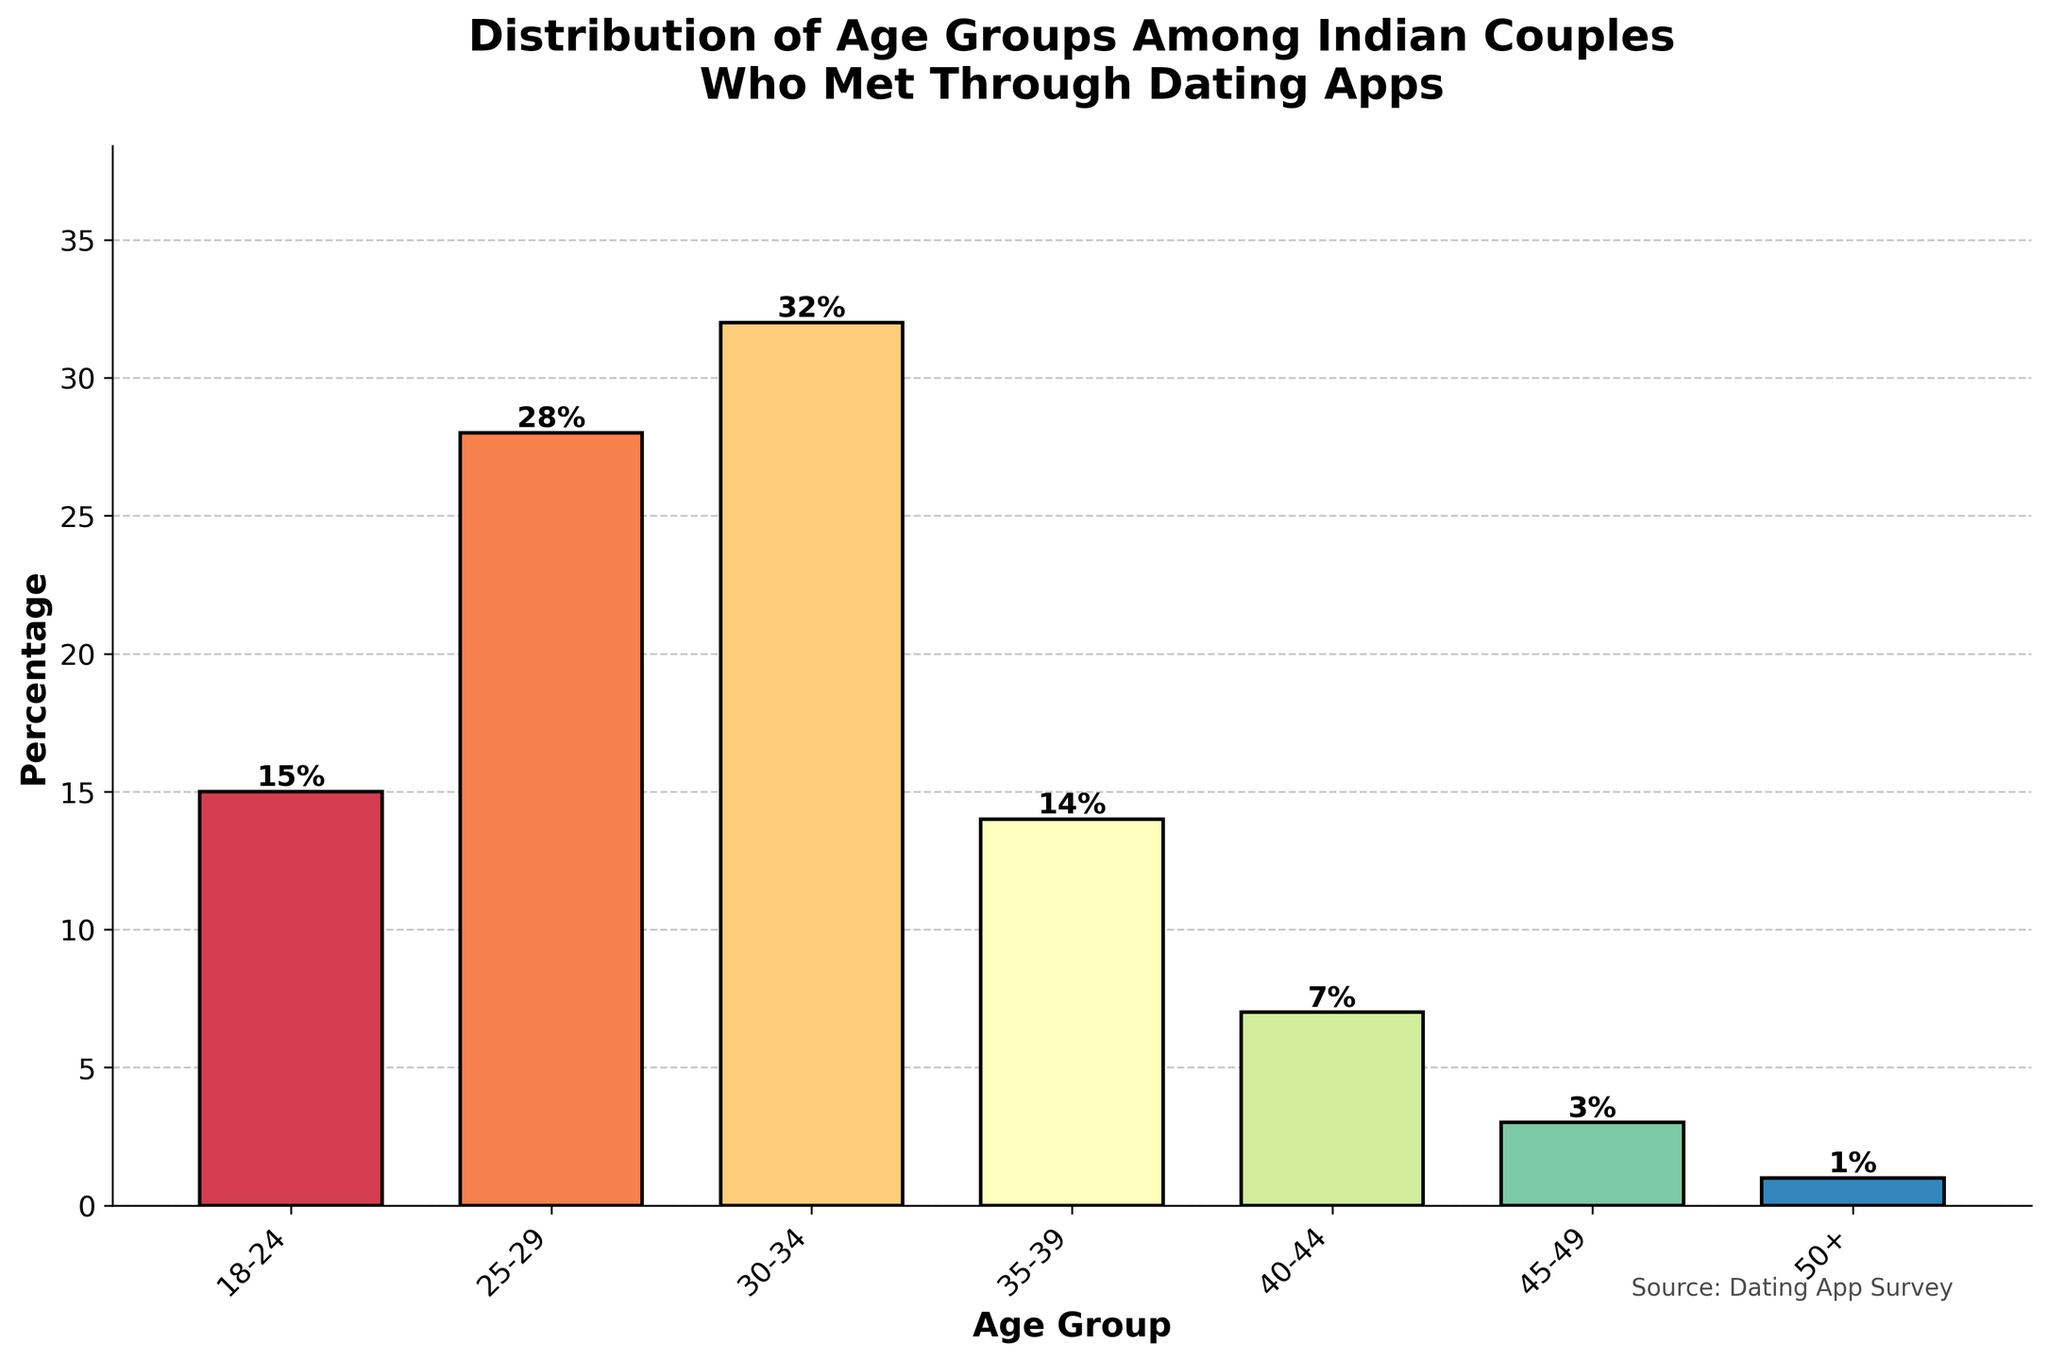What is the largest age group among Indian couples who met through dating apps? The age group with the highest percentage will have the tallest bar on the chart. By examining the heights, the age group 30-34 has the tallest bar representing 32%.
Answer: 30-34 What is the combined percentage of couples in the 25-29 and 30-34 age groups? To find the combined percentage, sum the percentages of the two age groups. The percentages are 28% and 32% respectively, so 28 + 32 = 60.
Answer: 60% Which age group has a higher percentage, 18-24 or 35-39? By comparing the heights of the bars for these two age groups, the 18-24 group has a higher percentage (15%) compared to the 35-39 group (14%).
Answer: 18-24 What is the percentage difference between the age groups 40-44 and 50+? Subtract the percentage of the 50+ age group from the percentage of the 40-44 age group. This is 7% - 1% = 6%.
Answer: 6% Which age group has the lowest percentage? The age group with the lowest percentage will have the shortest bar on the chart. The 50+ age group has the shortest bar representing 1%.
Answer: 50+ How many age groups have a percentage greater than 25%? By examining the chart, the age groups 25-29 (28%) and 30-34 (32%) both have percentages greater than 25%. Thus, there are 2 age groups.
Answer: 2 Which has a greater percentage: the group 25-29 combined with 35-39, or the group 18-24 combined with 40-44? Sum the percentages of each combination: 25-29 (28%) + 35-39 (14%) = 42%, and 18-24 (15%) + 40-44 (7%) = 22%. Compare these sums to find 42% is greater than 22%.
Answer: 25-29 combined with 35-39 What is the average percentage of the age groups 18-24, 35-39, and 50+? Find the average by summing the percentages of these age groups and dividing by the number of groups. This is (15% + 14% + 1%) / 3 = 10%.
Answer: 10% Which age groups have a combined percentage of more than 50% when summed? Determine possible combinations and sum their percentages: 30-34 (32%) + 25-29 (28%) = 60%, 30-34 (32%) + 18-24 (15%) + 25-29 (28%) = 75%, etc. Several combinations exceed 50%.
Answer: Multiple combinations Are there more couples in age groups 40-44 and 45-49 combined or in age group 30-34 alone? Sum the percentages of age groups 40-44 (7%) and 45-49 (3%) to get 10%, which is less than the 30-34 age group with 32%.
Answer: 30-34 alone 